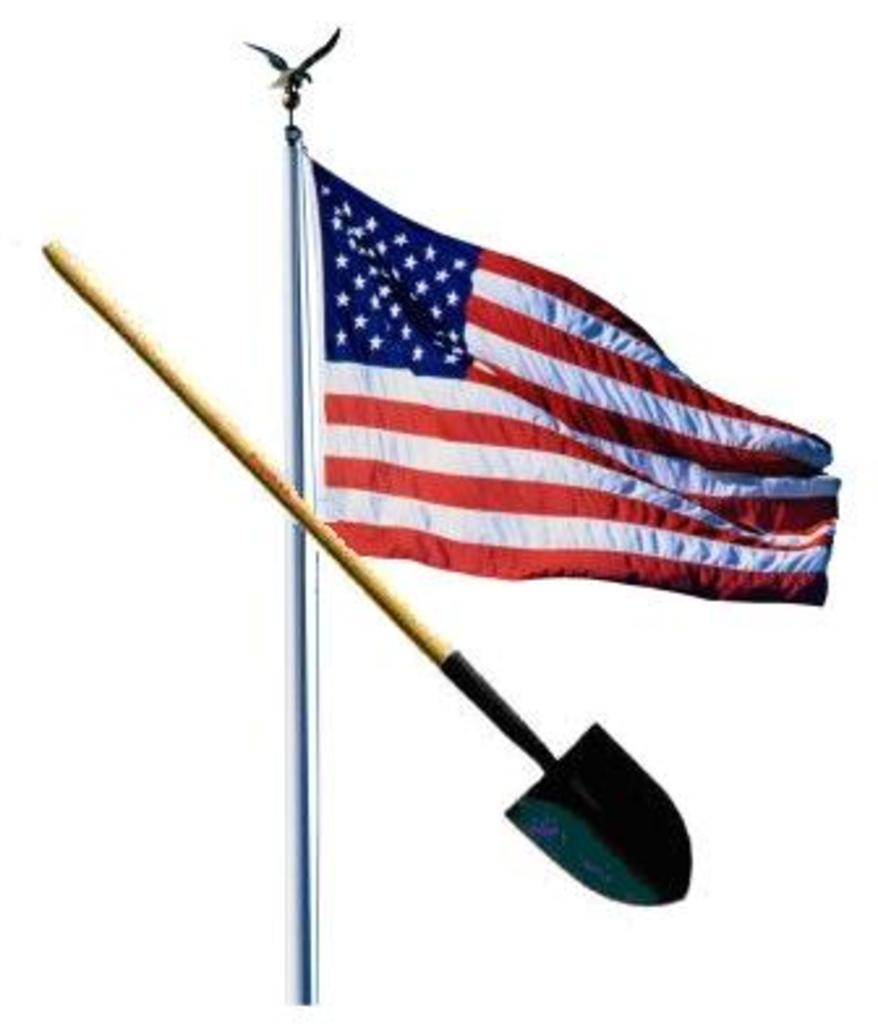What is the main subject of the image? There is a mud digger in the image. What else can be seen in the image besides the mud digger? There is a flag in the image. What colors are present on the flag? The flag has red, white, and navy blue colors. What is the color of the background in the image? The background of the image is white. What type of stomach is visible in the image? There is no stomach present in the image. How does the form of the mud digger change throughout the image? The form of the mud digger does not change throughout the image, as it is a static object. 